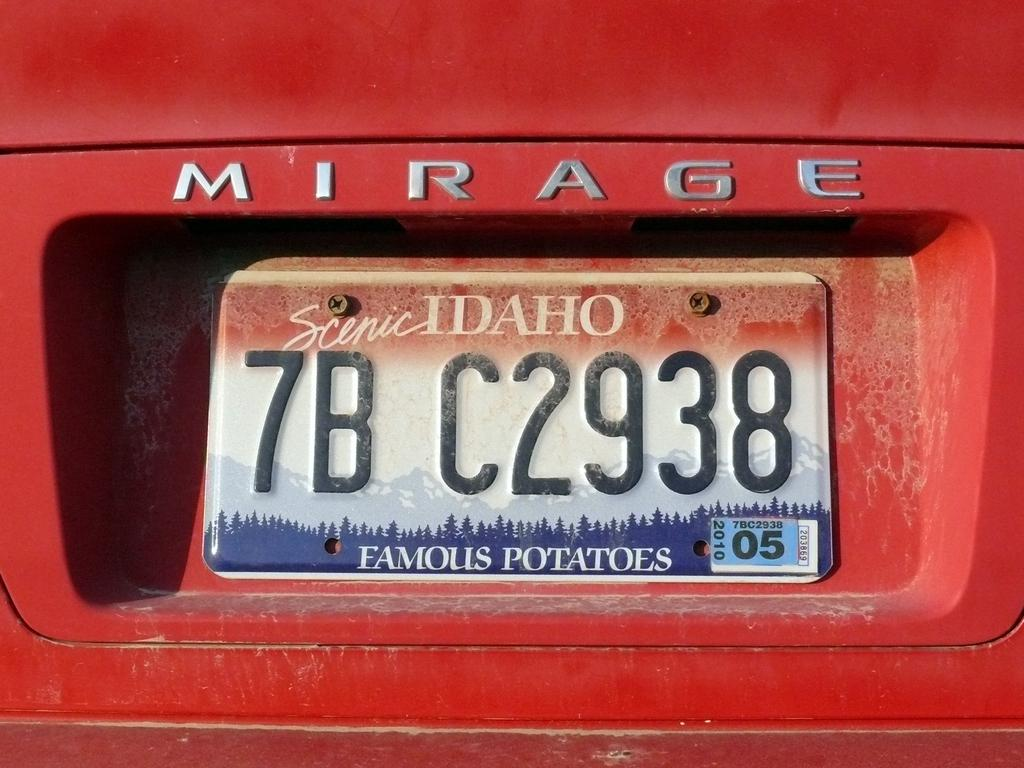Provide a one-sentence caption for the provided image. The back of a red Mirage car with an Idaho license plate with the numbers 7BC2938. 